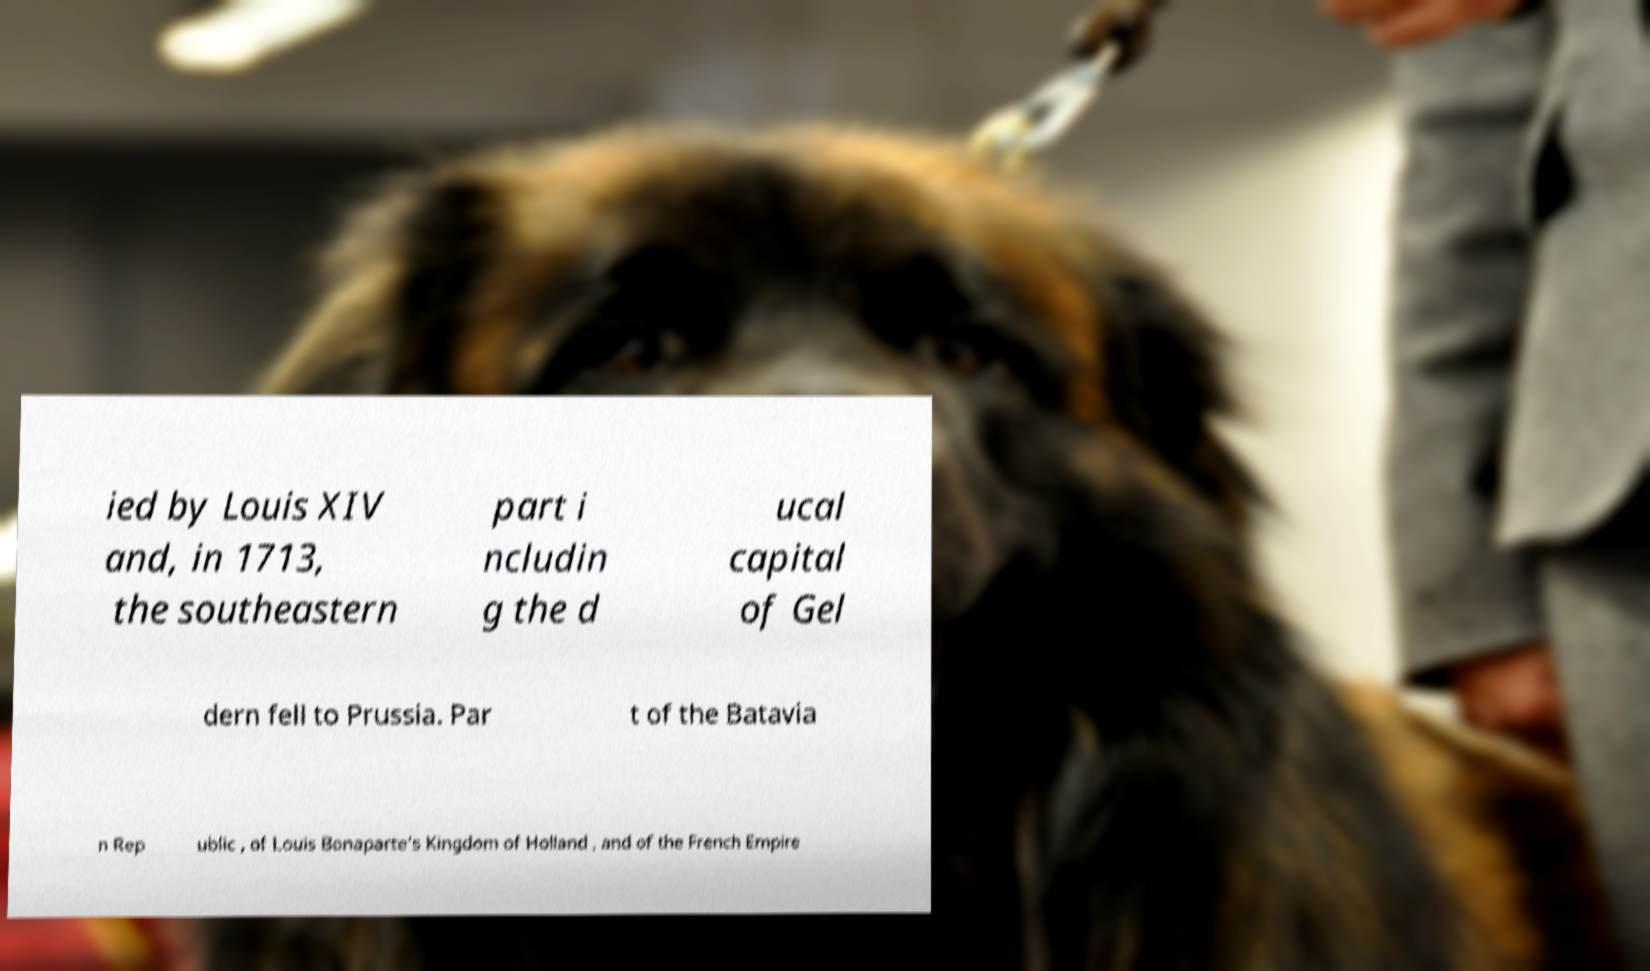Please identify and transcribe the text found in this image. ied by Louis XIV and, in 1713, the southeastern part i ncludin g the d ucal capital of Gel dern fell to Prussia. Par t of the Batavia n Rep ublic , of Louis Bonaparte’s Kingdom of Holland , and of the French Empire 